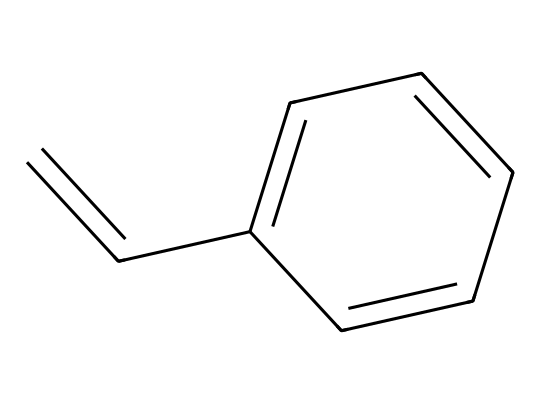What is the name of this chemical? The SMILES representation corresponds to styrene, which is a compound recognized for its aromatic properties. The structure shows a phenyl group attached to a vinyl group, leading to its common name.
Answer: styrene How many carbon atoms are in this molecule? Examining the SMILES, we can count the carbon atoms represented. The molecule has 8 carbon atoms in total: 6 from the benzene ring and 2 from the vinyl group.
Answer: 8 How many double bonds are present in this structure? By analyzing the structure, we see that there are 2 double bonds: one between the carbon atoms in the vinyl group and one in the aromatic ring.
Answer: 2 What characteristic of styrene makes it suitable for plastic floral arrangements? Styrene's structure contributes to its properties such as durability and lightweight nature, which are desirable in making plastic floral arrangements.
Answer: durability What type of hydrocarbon is styrene? Styrene is classified as an aromatic hydrocarbon due to its benzene ring, which exhibits resonance stability and chemical reactivity common in aromatic compounds.
Answer: aromatic Why is the presence of a double bond significant in styrene? The double bond in the vinyl group makes styrene a reactive monomer, allowing it to polymerize easily, which is crucial for forming polystyrene, a common plastic.
Answer: reactive monomer 